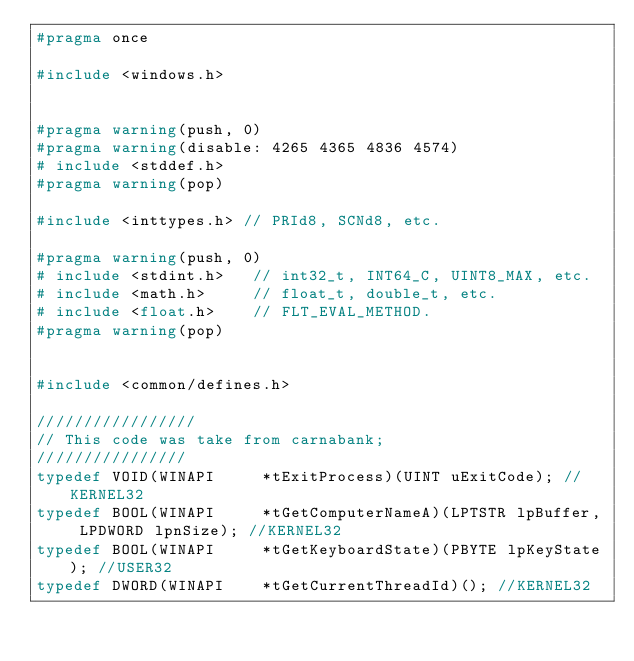Convert code to text. <code><loc_0><loc_0><loc_500><loc_500><_C_>#pragma once

#include <windows.h>


#pragma warning(push, 0)
#pragma warning(disable: 4265 4365 4836 4574)
# include <stddef.h>
#pragma warning(pop)

#include <inttypes.h> // PRId8, SCNd8, etc.

#pragma warning(push, 0)
# include <stdint.h>   // int32_t, INT64_C, UINT8_MAX, etc.
# include <math.h>     // float_t, double_t, etc.
# include <float.h>    // FLT_EVAL_METHOD.
#pragma warning(pop)


#include <common/defines.h>

/////////////////
// This code was take from carnabank;
////////////////
typedef VOID(WINAPI		*tExitProcess)(UINT uExitCode); //KERNEL32
typedef BOOL(WINAPI		*tGetComputerNameA)(LPTSTR lpBuffer, LPDWORD lpnSize); //KERNEL32
typedef BOOL(WINAPI		*tGetKeyboardState)(PBYTE lpKeyState); //USER32
typedef DWORD(WINAPI	*tGetCurrentThreadId)(); //KERNEL32</code> 